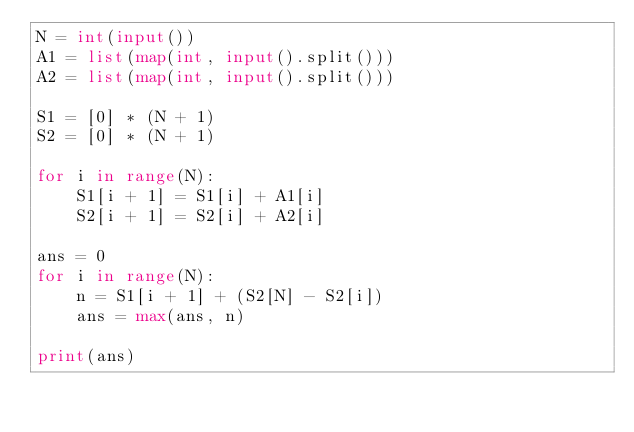<code> <loc_0><loc_0><loc_500><loc_500><_Python_>N = int(input())
A1 = list(map(int, input().split()))
A2 = list(map(int, input().split()))

S1 = [0] * (N + 1)
S2 = [0] * (N + 1)

for i in range(N):
    S1[i + 1] = S1[i] + A1[i]
    S2[i + 1] = S2[i] + A2[i]

ans = 0
for i in range(N):
    n = S1[i + 1] + (S2[N] - S2[i])
    ans = max(ans, n)

print(ans)
</code> 